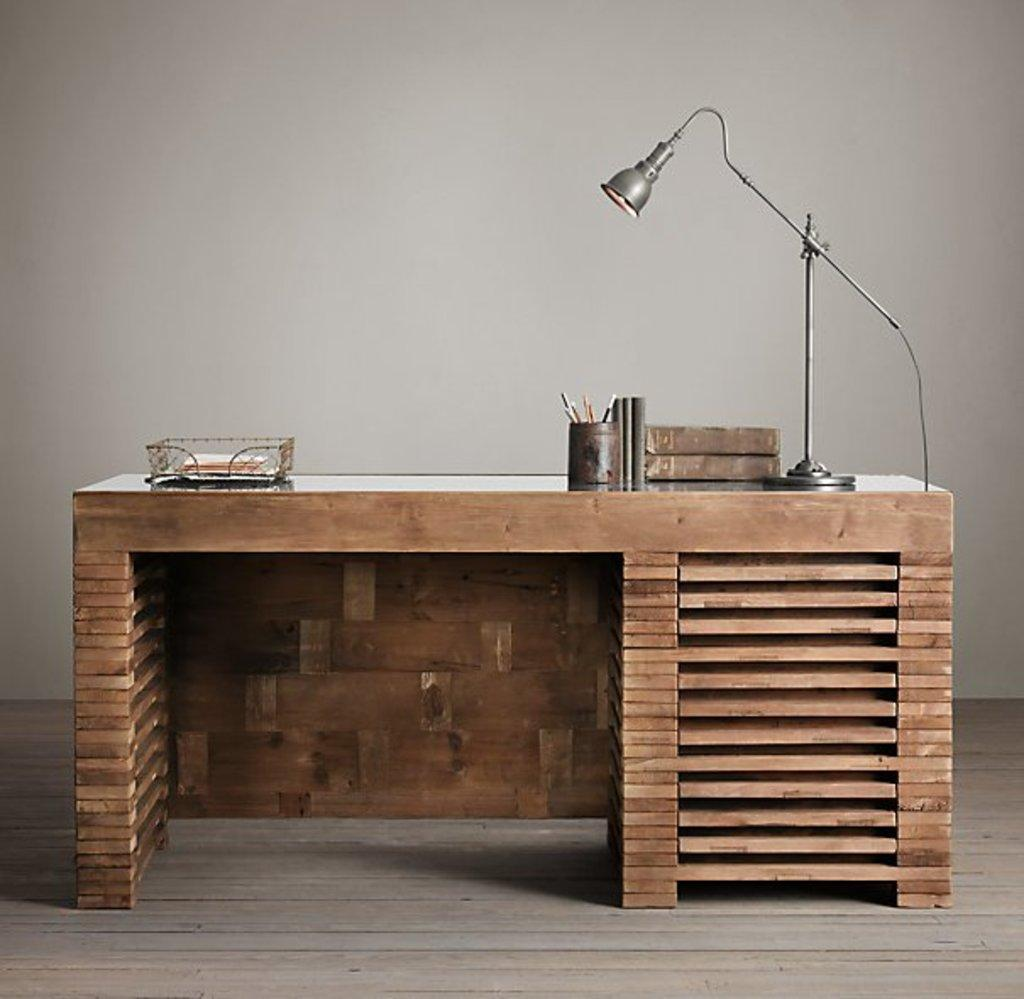What piece of furniture is in the image? There is a desk in the image. What items can be seen on the desk? There are books, a lamp, a cable, a cup, pens, letters, and other objects on the desk. What type of lighting is present on the desk? There is a lamp on the desk. What might be used for writing on the desk? The pens on the desk can be used for writing. What is visible at the bottom of the image? The floor is visible at the bottom of the image. What is in the background of the image? There is a well in the background of the image. How many hens are sitting on the desk in the image? There are no hens present on the desk in the image. What type of sponge can be seen cleaning the well in the background? There is no sponge visible in the image, and the well in the background is not being cleaned. 